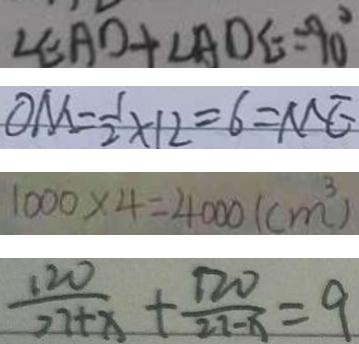Convert formula to latex. <formula><loc_0><loc_0><loc_500><loc_500>\angle E A O + \angle A O E = 9 0 ^ { \circ } 
 O M = \frac { 1 } { 2 } \times 1 2 = 6 = M E 
 1 0 0 0 \times 4 = 4 0 0 0 ( c m ^ { 3 } ) 
 \frac { 1 2 0 } { 2 7 + x } + \frac { 1 2 0 } { 2 2 - x } = 9</formula> 